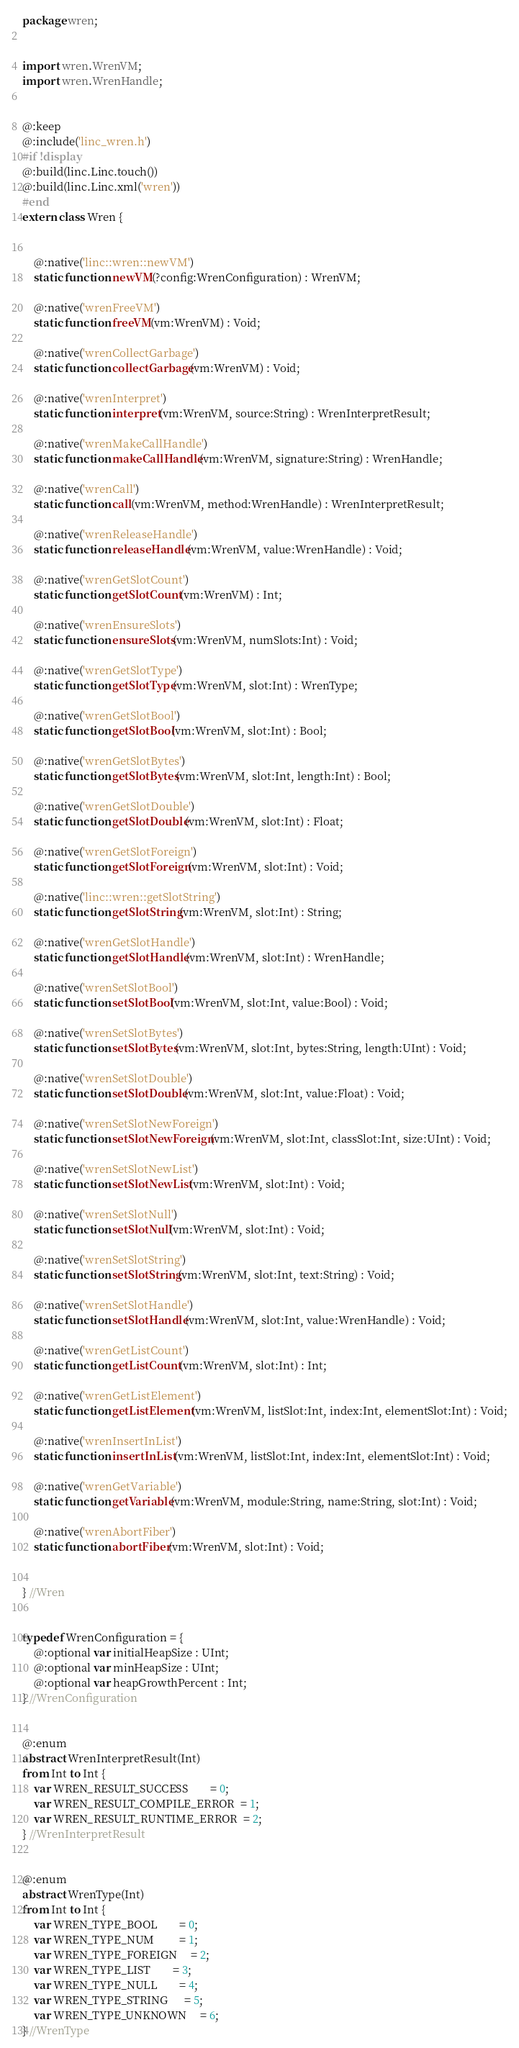Convert code to text. <code><loc_0><loc_0><loc_500><loc_500><_Haxe_>package wren;


import wren.WrenVM;
import wren.WrenHandle;


@:keep
@:include('linc_wren.h')
#if !display
@:build(linc.Linc.touch())
@:build(linc.Linc.xml('wren'))
#end
extern class Wren {


	@:native('linc::wren::newVM')
	static function newVM(?config:WrenConfiguration) : WrenVM;

	@:native('wrenFreeVM')
	static function freeVM(vm:WrenVM) : Void;

	@:native('wrenCollectGarbage')
	static function collectGarbage(vm:WrenVM) : Void;

	@:native('wrenInterpret')
	static function interpret(vm:WrenVM, source:String) : WrenInterpretResult;

	@:native('wrenMakeCallHandle')
	static function makeCallHandle(vm:WrenVM, signature:String) : WrenHandle;

	@:native('wrenCall')
	static function call(vm:WrenVM, method:WrenHandle) : WrenInterpretResult;

	@:native('wrenReleaseHandle')
	static function releaseHandle(vm:WrenVM, value:WrenHandle) : Void;

	@:native('wrenGetSlotCount')
	static function getSlotCount(vm:WrenVM) : Int;

	@:native('wrenEnsureSlots')
	static function ensureSlots(vm:WrenVM, numSlots:Int) : Void;

	@:native('wrenGetSlotType')
	static function getSlotType(vm:WrenVM, slot:Int) : WrenType;

	@:native('wrenGetSlotBool')
	static function getSlotBool(vm:WrenVM, slot:Int) : Bool;

	@:native('wrenGetSlotBytes')
	static function getSlotBytes(vm:WrenVM, slot:Int, length:Int) : Bool;

	@:native('wrenGetSlotDouble')
	static function getSlotDouble(vm:WrenVM, slot:Int) : Float;

	@:native('wrenGetSlotForeign')
	static function getSlotForeign(vm:WrenVM, slot:Int) : Void;

	@:native('linc::wren::getSlotString')
	static function getSlotString(vm:WrenVM, slot:Int) : String;

	@:native('wrenGetSlotHandle')
	static function getSlotHandle(vm:WrenVM, slot:Int) : WrenHandle;

	@:native('wrenSetSlotBool')
	static function setSlotBool(vm:WrenVM, slot:Int, value:Bool) : Void;

	@:native('wrenSetSlotBytes')
	static function setSlotBytes(vm:WrenVM, slot:Int, bytes:String, length:UInt) : Void;

	@:native('wrenSetSlotDouble')
	static function setSlotDouble(vm:WrenVM, slot:Int, value:Float) : Void;

	@:native('wrenSetSlotNewForeign')
	static function setSlotNewForeign(vm:WrenVM, slot:Int, classSlot:Int, size:UInt) : Void;

	@:native('wrenSetSlotNewList')
	static function setSlotNewList(vm:WrenVM, slot:Int) : Void;

	@:native('wrenSetSlotNull')
	static function setSlotNull(vm:WrenVM, slot:Int) : Void;

	@:native('wrenSetSlotString')
	static function setSlotString(vm:WrenVM, slot:Int, text:String) : Void;

	@:native('wrenSetSlotHandle')
	static function setSlotHandle(vm:WrenVM, slot:Int, value:WrenHandle) : Void;

	@:native('wrenGetListCount')
	static function getListCount(vm:WrenVM, slot:Int) : Int;

	@:native('wrenGetListElement')
	static function getListElement(vm:WrenVM, listSlot:Int, index:Int, elementSlot:Int) : Void;

	@:native('wrenInsertInList')
	static function insertInList(vm:WrenVM, listSlot:Int, index:Int, elementSlot:Int) : Void;

	@:native('wrenGetVariable')
	static function getVariable(vm:WrenVM, module:String, name:String, slot:Int) : Void;

	@:native('wrenAbortFiber')
	static function abortFiber(vm:WrenVM, slot:Int) : Void;
	

} //Wren


typedef WrenConfiguration = {
	@:optional var initialHeapSize : UInt;
	@:optional var minHeapSize : UInt;
	@:optional var heapGrowthPercent : Int;
} //WrenConfiguration


@:enum
abstract WrenInterpretResult(Int)
from Int to Int {
	var WREN_RESULT_SUCCESS        = 0;
	var WREN_RESULT_COMPILE_ERROR  = 1;
	var WREN_RESULT_RUNTIME_ERROR  = 2;
} //WrenInterpretResult


@:enum
abstract WrenType(Int)
from Int to Int {
	var WREN_TYPE_BOOL        = 0;
	var WREN_TYPE_NUM         = 1;
	var WREN_TYPE_FOREIGN     = 2;
	var WREN_TYPE_LIST        = 3;
	var WREN_TYPE_NULL        = 4;
	var WREN_TYPE_STRING      = 5;
	var WREN_TYPE_UNKNOWN     = 6;
} //WrenType
</code> 